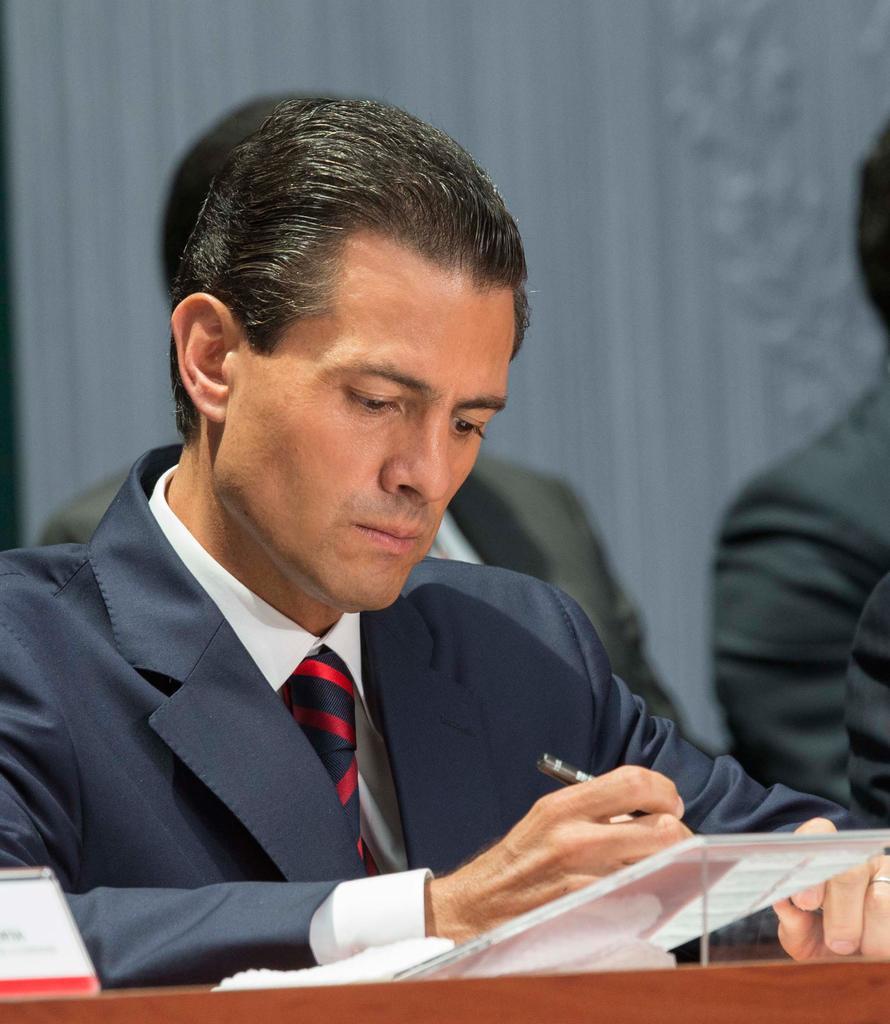Could you give a brief overview of what you see in this image? In the picture I can see people among the man in the front is holding an object in the hand. The man is wearing a tie, a shirt and a coat. The background of the image is blurred. 